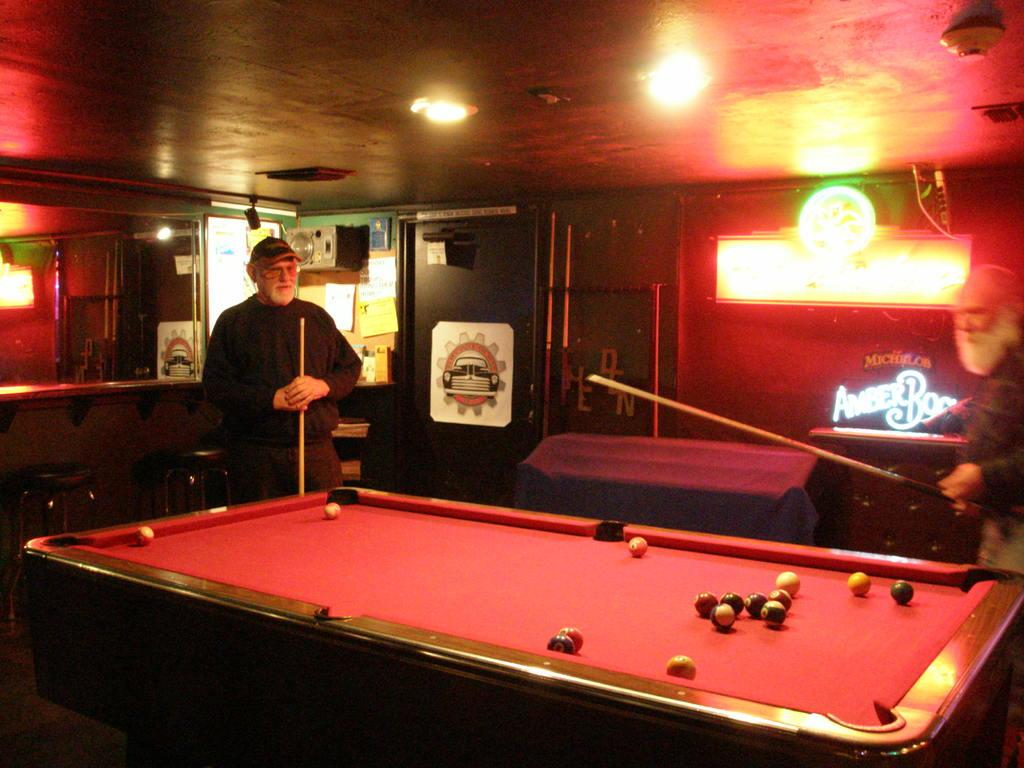How many people are in the image? There are two persons in the image. What are the two persons doing in the image? The two persons are playing. What objects can be seen in the image that are related to their play? There are balls visible in the image. What type of rifle can be seen in the image? There is no rifle present in the image. Can you tell me which berry is being used as a prop in the image? There is no berry present in the image. 